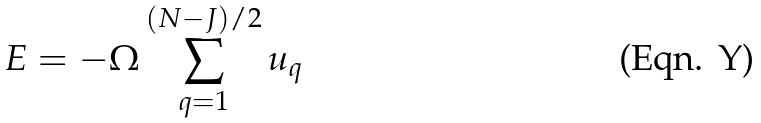Convert formula to latex. <formula><loc_0><loc_0><loc_500><loc_500>E = - \Omega \sum _ { q = 1 } ^ { ( N - J ) / 2 } u _ { q }</formula> 